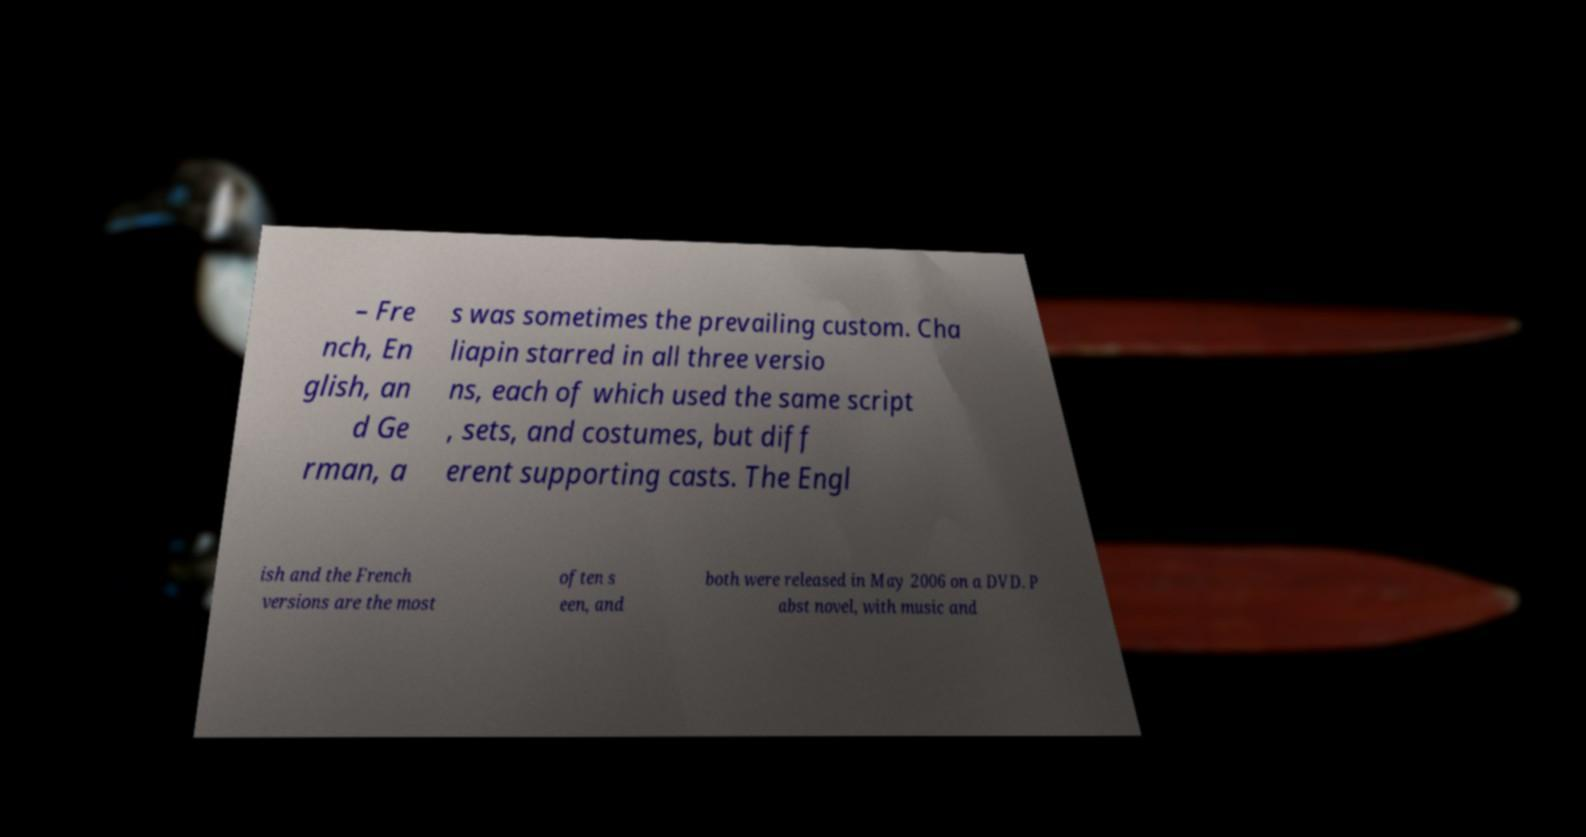Could you extract and type out the text from this image? – Fre nch, En glish, an d Ge rman, a s was sometimes the prevailing custom. Cha liapin starred in all three versio ns, each of which used the same script , sets, and costumes, but diff erent supporting casts. The Engl ish and the French versions are the most often s een, and both were released in May 2006 on a DVD. P abst novel, with music and 